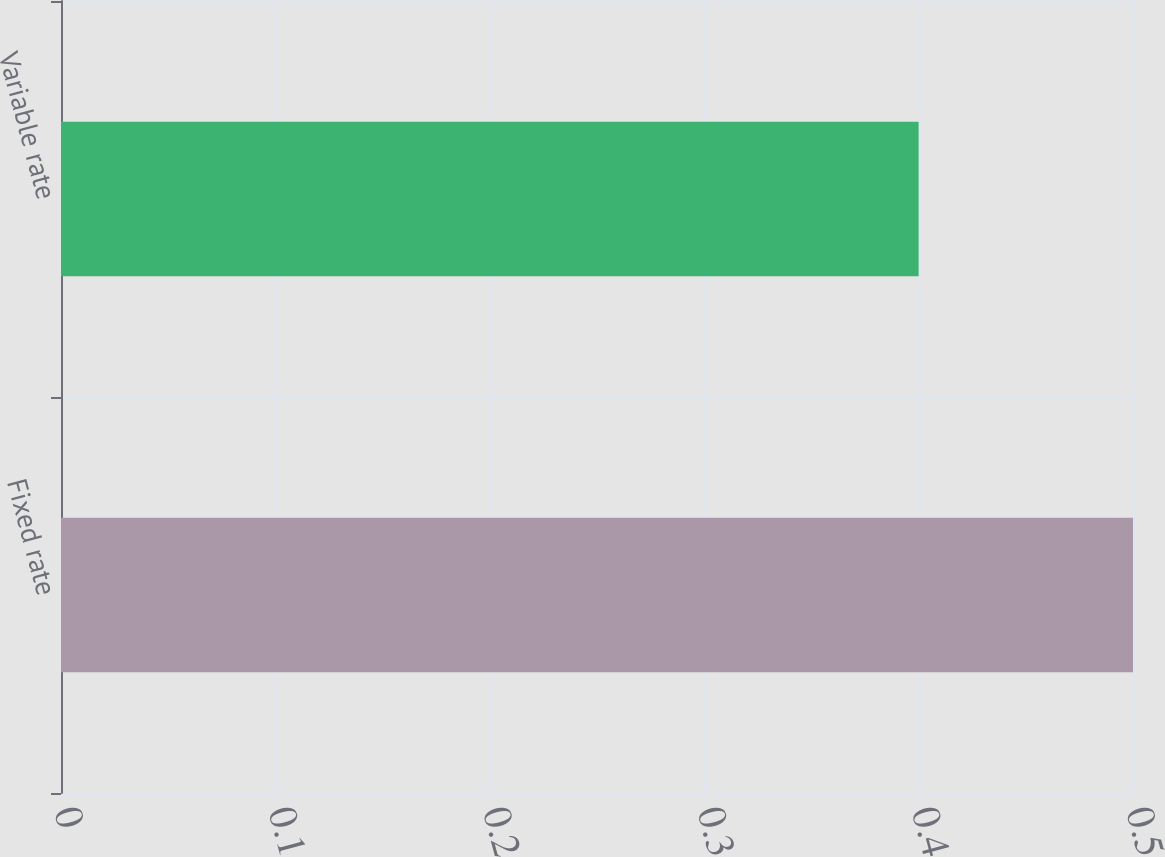Convert chart to OTSL. <chart><loc_0><loc_0><loc_500><loc_500><bar_chart><fcel>Fixed rate<fcel>Variable rate<nl><fcel>0.5<fcel>0.4<nl></chart> 